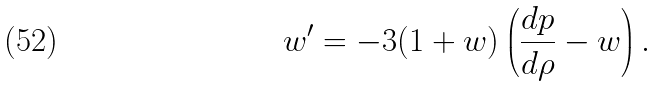Convert formula to latex. <formula><loc_0><loc_0><loc_500><loc_500>w ^ { \prime } = - 3 ( 1 + w ) \left ( \frac { d p } { d \rho } - w \right ) .</formula> 